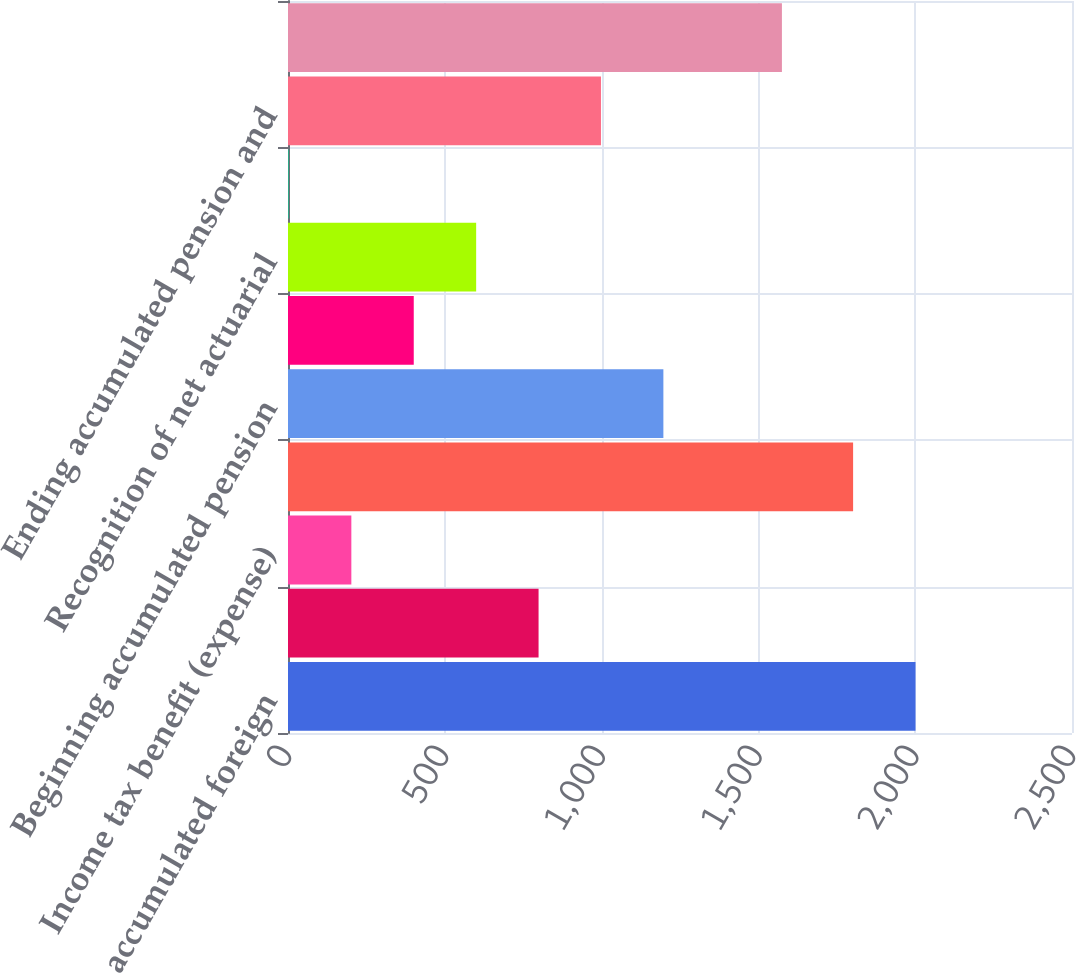Convert chart to OTSL. <chart><loc_0><loc_0><loc_500><loc_500><bar_chart><fcel>Beginning accumulated foreign<fcel>Change in cumulative<fcel>Income tax benefit (expense)<fcel>Ending accumulated foreign<fcel>Beginning accumulated pension<fcel>Net actuarial gain (loss) and<fcel>Recognition of net actuarial<fcel>Income tax expense<fcel>Ending accumulated pension and<fcel>Accumulated other<nl><fcel>2001<fcel>799<fcel>202<fcel>1802<fcel>1197<fcel>401<fcel>600<fcel>3<fcel>998<fcel>1575<nl></chart> 